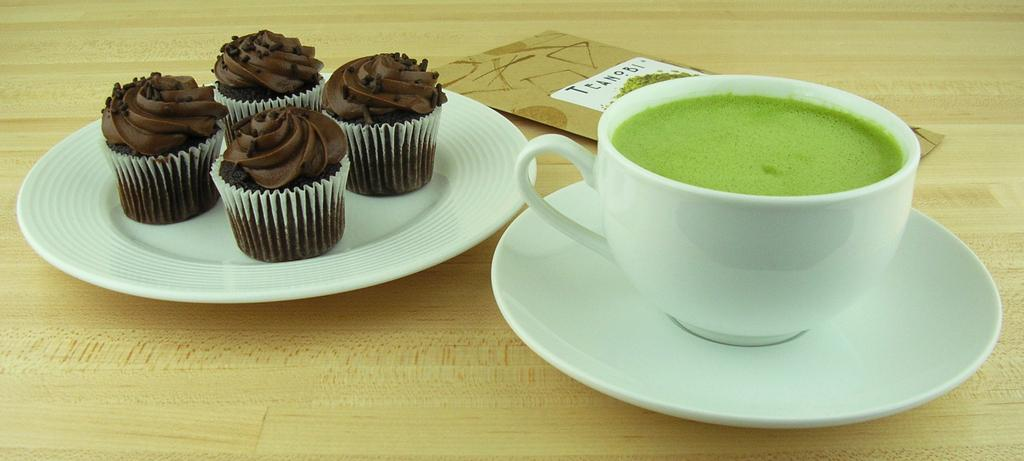What is placed on the wooden surface in the image? There is a plate, a saucer, a cup with a drink, muffins, and a card on the wooden surface. What type of container is holding the drink in the image? There is a cup with a drink on the wooden surface. What type of food can be seen on the wooden surface? There are muffins on the wooden surface. What else is present on the wooden surface besides the food and drink? There is a card on the wooden surface. How does the mark on the wooden surface begin to slip in the image? There is no mark present in the image, and therefore no such activity can be observed. 